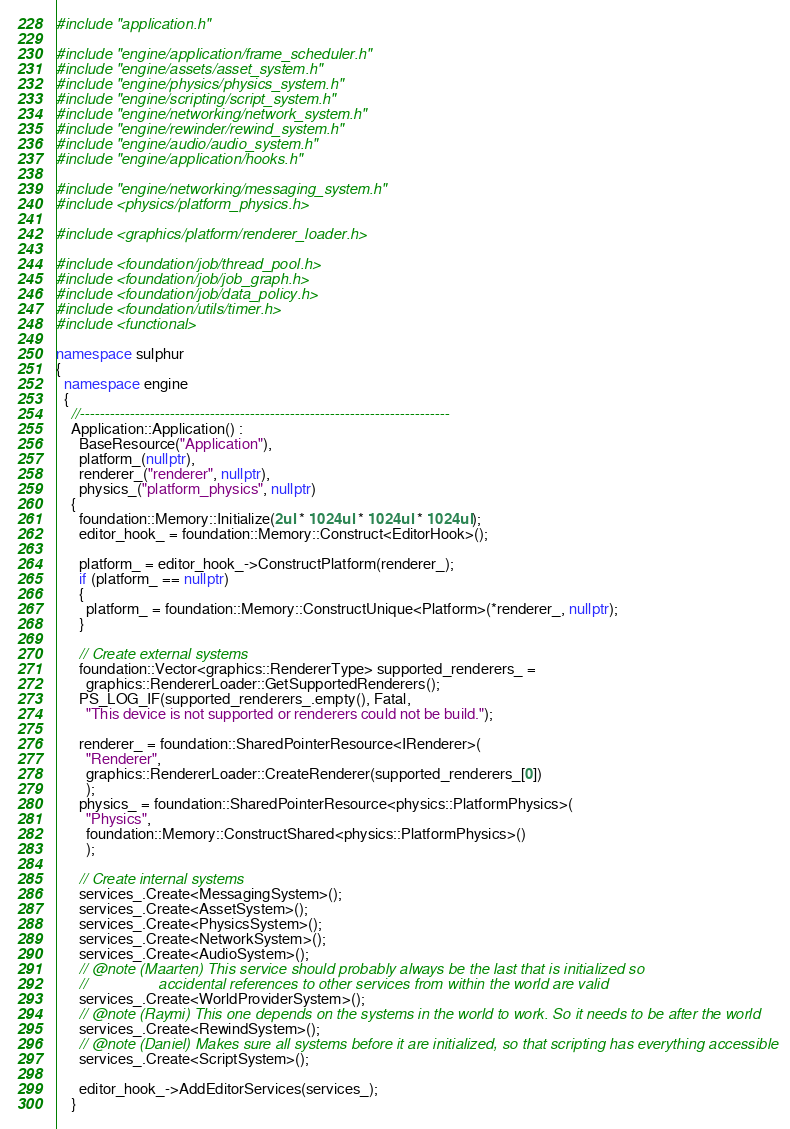Convert code to text. <code><loc_0><loc_0><loc_500><loc_500><_C++_>#include "application.h"

#include "engine/application/frame_scheduler.h"
#include "engine/assets/asset_system.h"
#include "engine/physics/physics_system.h"
#include "engine/scripting/script_system.h"
#include "engine/networking/network_system.h"
#include "engine/rewinder/rewind_system.h"
#include "engine/audio/audio_system.h"
#include "engine/application/hooks.h"

#include "engine/networking/messaging_system.h"
#include <physics/platform_physics.h>

#include <graphics/platform/renderer_loader.h>

#include <foundation/job/thread_pool.h>
#include <foundation/job/job_graph.h>
#include <foundation/job/data_policy.h>
#include <foundation/utils/timer.h>
#include <functional>

namespace sulphur
{
  namespace engine
  {
    //--------------------------------------------------------------------------
    Application::Application() :
      BaseResource("Application"),
      platform_(nullptr),
      renderer_("renderer", nullptr),
      physics_("platform_physics", nullptr)
    {
      foundation::Memory::Initialize(2ul * 1024ul * 1024ul * 1024ul);
      editor_hook_ = foundation::Memory::Construct<EditorHook>();

      platform_ = editor_hook_->ConstructPlatform(renderer_);
      if (platform_ == nullptr)
      {
        platform_ = foundation::Memory::ConstructUnique<Platform>(*renderer_, nullptr);
      }

      // Create external systems
      foundation::Vector<graphics::RendererType> supported_renderers_ =
        graphics::RendererLoader::GetSupportedRenderers();
      PS_LOG_IF(supported_renderers_.empty(), Fatal,
        "This device is not supported or renderers could not be build.");

      renderer_ = foundation::SharedPointerResource<IRenderer>(
        "Renderer",
        graphics::RendererLoader::CreateRenderer(supported_renderers_[0])
        );
      physics_ = foundation::SharedPointerResource<physics::PlatformPhysics>(
        "Physics",
        foundation::Memory::ConstructShared<physics::PlatformPhysics>()
        );

      // Create internal systems
      services_.Create<MessagingSystem>();
      services_.Create<AssetSystem>();
      services_.Create<PhysicsSystem>();
      services_.Create<NetworkSystem>();
      services_.Create<AudioSystem>();
      // @note (Maarten) This service should probably always be the last that is initialized so 
      //                 accidental references to other services from within the world are valid
      services_.Create<WorldProviderSystem>();
      // @note (Raymi) This one depends on the systems in the world to work. So it needs to be after the world
      services_.Create<RewindSystem>();
      // @note (Daniel) Makes sure all systems before it are initialized, so that scripting has everything accessible
      services_.Create<ScriptSystem>();

      editor_hook_->AddEditorServices(services_);
    }
</code> 